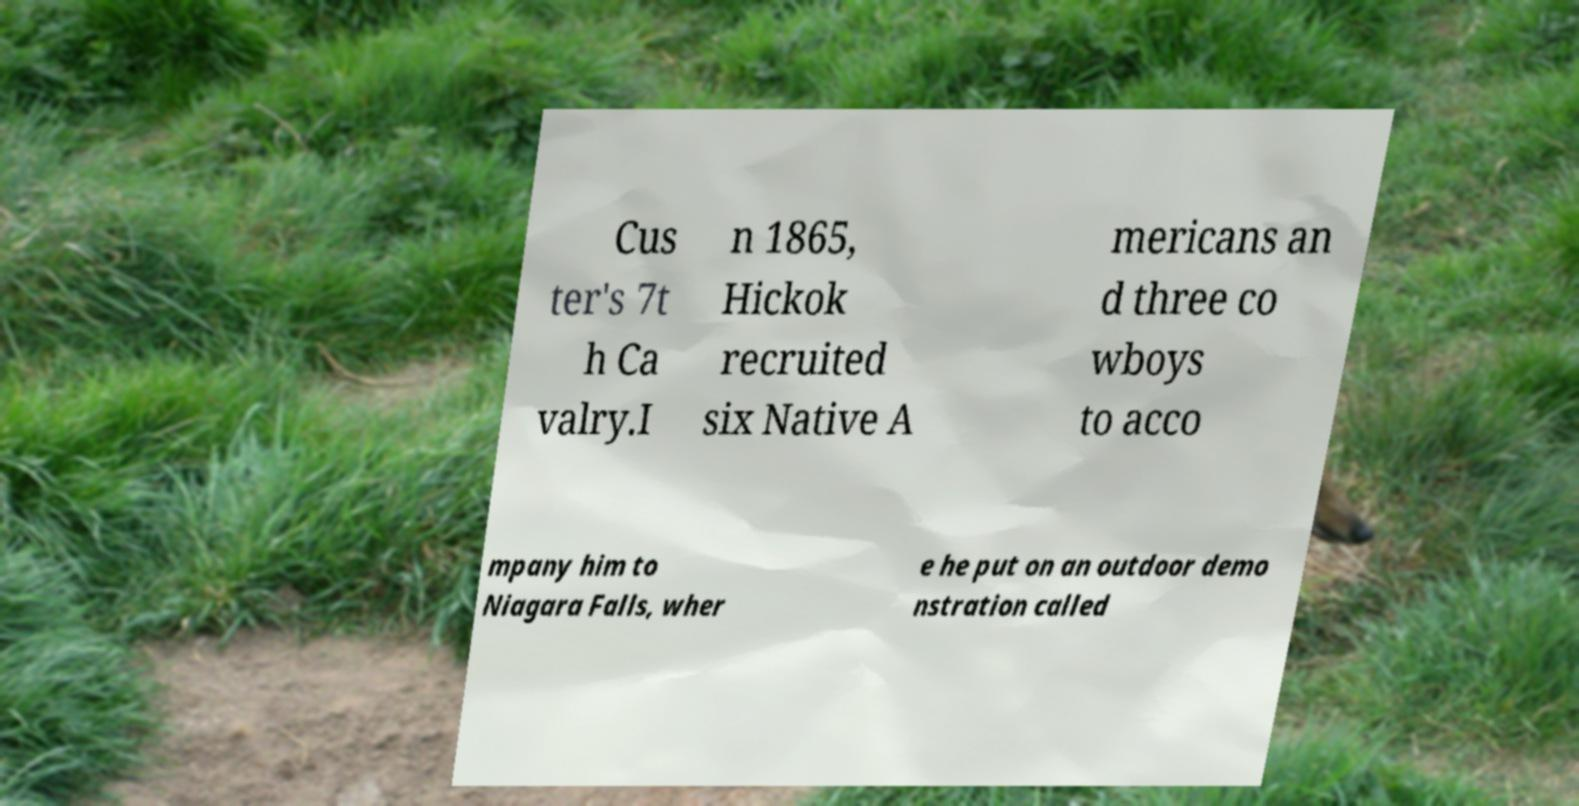What messages or text are displayed in this image? I need them in a readable, typed format. Cus ter's 7t h Ca valry.I n 1865, Hickok recruited six Native A mericans an d three co wboys to acco mpany him to Niagara Falls, wher e he put on an outdoor demo nstration called 